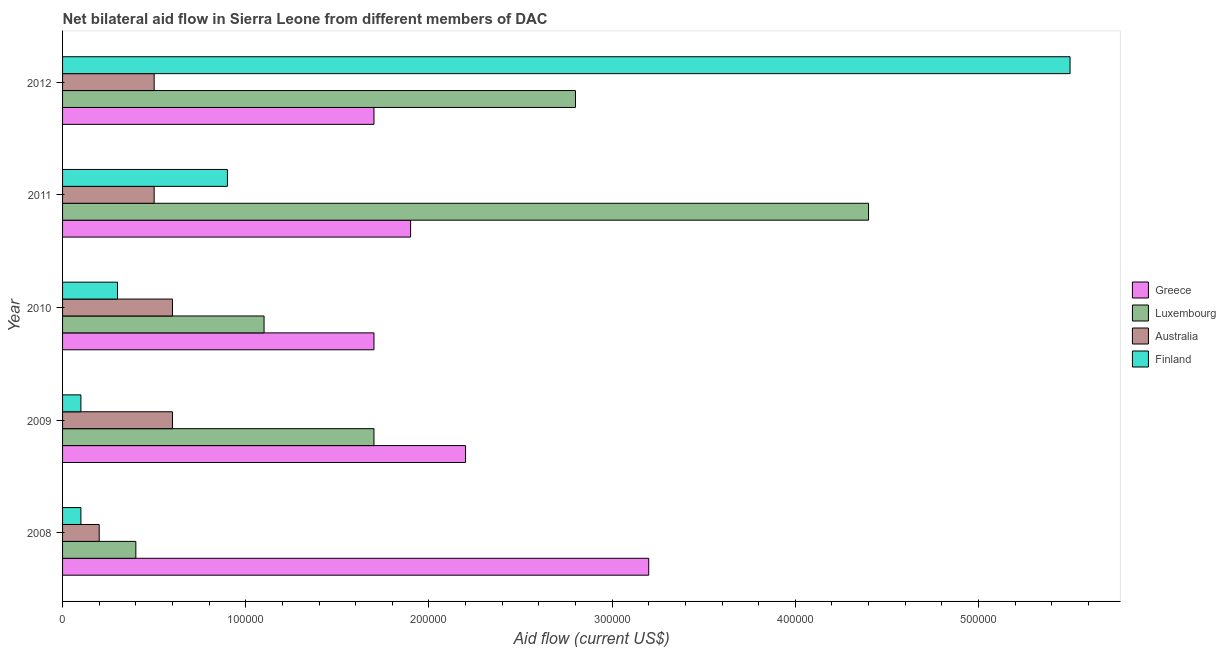How many groups of bars are there?
Provide a short and direct response. 5. How many bars are there on the 5th tick from the bottom?
Offer a very short reply. 4. In how many cases, is the number of bars for a given year not equal to the number of legend labels?
Ensure brevity in your answer.  0. What is the amount of aid given by greece in 2011?
Provide a short and direct response. 1.90e+05. Across all years, what is the maximum amount of aid given by luxembourg?
Offer a terse response. 4.40e+05. Across all years, what is the minimum amount of aid given by finland?
Ensure brevity in your answer.  10000. What is the total amount of aid given by australia in the graph?
Provide a short and direct response. 2.40e+05. What is the difference between the amount of aid given by finland in 2010 and that in 2012?
Offer a terse response. -5.20e+05. What is the difference between the amount of aid given by greece in 2010 and the amount of aid given by australia in 2011?
Ensure brevity in your answer.  1.20e+05. What is the average amount of aid given by greece per year?
Provide a succinct answer. 2.14e+05. In the year 2009, what is the difference between the amount of aid given by greece and amount of aid given by australia?
Offer a terse response. 1.60e+05. In how many years, is the amount of aid given by greece greater than 360000 US$?
Offer a very short reply. 0. What is the ratio of the amount of aid given by greece in 2009 to that in 2011?
Your answer should be compact. 1.16. What is the difference between the highest and the lowest amount of aid given by finland?
Give a very brief answer. 5.40e+05. Is the sum of the amount of aid given by luxembourg in 2008 and 2010 greater than the maximum amount of aid given by finland across all years?
Your answer should be compact. No. Is it the case that in every year, the sum of the amount of aid given by luxembourg and amount of aid given by australia is greater than the sum of amount of aid given by greece and amount of aid given by finland?
Your answer should be very brief. No. What does the 4th bar from the top in 2010 represents?
Offer a very short reply. Greece. What does the 2nd bar from the bottom in 2012 represents?
Your answer should be compact. Luxembourg. How many years are there in the graph?
Provide a succinct answer. 5. What is the difference between two consecutive major ticks on the X-axis?
Make the answer very short. 1.00e+05. Does the graph contain grids?
Offer a very short reply. No. How many legend labels are there?
Your answer should be very brief. 4. What is the title of the graph?
Provide a succinct answer. Net bilateral aid flow in Sierra Leone from different members of DAC. What is the label or title of the X-axis?
Offer a very short reply. Aid flow (current US$). What is the label or title of the Y-axis?
Make the answer very short. Year. What is the Aid flow (current US$) of Greece in 2008?
Ensure brevity in your answer.  3.20e+05. What is the Aid flow (current US$) in Greece in 2009?
Offer a terse response. 2.20e+05. What is the Aid flow (current US$) of Australia in 2009?
Ensure brevity in your answer.  6.00e+04. What is the Aid flow (current US$) in Greece in 2010?
Provide a short and direct response. 1.70e+05. What is the Aid flow (current US$) in Greece in 2011?
Offer a terse response. 1.90e+05. What is the Aid flow (current US$) of Luxembourg in 2011?
Ensure brevity in your answer.  4.40e+05. What is the Aid flow (current US$) in Finland in 2011?
Offer a very short reply. 9.00e+04. What is the Aid flow (current US$) in Greece in 2012?
Offer a very short reply. 1.70e+05. Across all years, what is the maximum Aid flow (current US$) in Greece?
Keep it short and to the point. 3.20e+05. Across all years, what is the maximum Aid flow (current US$) in Luxembourg?
Your answer should be compact. 4.40e+05. Across all years, what is the maximum Aid flow (current US$) of Australia?
Your response must be concise. 6.00e+04. Across all years, what is the maximum Aid flow (current US$) of Finland?
Make the answer very short. 5.50e+05. Across all years, what is the minimum Aid flow (current US$) in Luxembourg?
Your answer should be very brief. 4.00e+04. Across all years, what is the minimum Aid flow (current US$) in Finland?
Your answer should be compact. 10000. What is the total Aid flow (current US$) of Greece in the graph?
Ensure brevity in your answer.  1.07e+06. What is the total Aid flow (current US$) of Luxembourg in the graph?
Ensure brevity in your answer.  1.04e+06. What is the total Aid flow (current US$) of Australia in the graph?
Your answer should be compact. 2.40e+05. What is the total Aid flow (current US$) in Finland in the graph?
Your response must be concise. 6.90e+05. What is the difference between the Aid flow (current US$) in Greece in 2008 and that in 2009?
Give a very brief answer. 1.00e+05. What is the difference between the Aid flow (current US$) in Greece in 2008 and that in 2010?
Make the answer very short. 1.50e+05. What is the difference between the Aid flow (current US$) of Luxembourg in 2008 and that in 2010?
Make the answer very short. -7.00e+04. What is the difference between the Aid flow (current US$) in Greece in 2008 and that in 2011?
Offer a terse response. 1.30e+05. What is the difference between the Aid flow (current US$) of Luxembourg in 2008 and that in 2011?
Your answer should be compact. -4.00e+05. What is the difference between the Aid flow (current US$) of Australia in 2008 and that in 2011?
Provide a succinct answer. -3.00e+04. What is the difference between the Aid flow (current US$) of Australia in 2008 and that in 2012?
Offer a terse response. -3.00e+04. What is the difference between the Aid flow (current US$) of Finland in 2008 and that in 2012?
Make the answer very short. -5.40e+05. What is the difference between the Aid flow (current US$) of Greece in 2009 and that in 2010?
Your answer should be compact. 5.00e+04. What is the difference between the Aid flow (current US$) of Luxembourg in 2009 and that in 2010?
Ensure brevity in your answer.  6.00e+04. What is the difference between the Aid flow (current US$) of Australia in 2009 and that in 2010?
Ensure brevity in your answer.  0. What is the difference between the Aid flow (current US$) in Finland in 2009 and that in 2010?
Your response must be concise. -2.00e+04. What is the difference between the Aid flow (current US$) of Greece in 2009 and that in 2011?
Your answer should be very brief. 3.00e+04. What is the difference between the Aid flow (current US$) of Luxembourg in 2009 and that in 2011?
Make the answer very short. -2.70e+05. What is the difference between the Aid flow (current US$) of Australia in 2009 and that in 2011?
Offer a terse response. 10000. What is the difference between the Aid flow (current US$) in Finland in 2009 and that in 2012?
Ensure brevity in your answer.  -5.40e+05. What is the difference between the Aid flow (current US$) of Greece in 2010 and that in 2011?
Provide a short and direct response. -2.00e+04. What is the difference between the Aid flow (current US$) of Luxembourg in 2010 and that in 2011?
Give a very brief answer. -3.30e+05. What is the difference between the Aid flow (current US$) of Australia in 2010 and that in 2011?
Keep it short and to the point. 10000. What is the difference between the Aid flow (current US$) in Finland in 2010 and that in 2011?
Your answer should be very brief. -6.00e+04. What is the difference between the Aid flow (current US$) in Australia in 2010 and that in 2012?
Your response must be concise. 10000. What is the difference between the Aid flow (current US$) in Finland in 2010 and that in 2012?
Offer a terse response. -5.20e+05. What is the difference between the Aid flow (current US$) in Australia in 2011 and that in 2012?
Ensure brevity in your answer.  0. What is the difference between the Aid flow (current US$) in Finland in 2011 and that in 2012?
Provide a succinct answer. -4.60e+05. What is the difference between the Aid flow (current US$) in Greece in 2008 and the Aid flow (current US$) in Luxembourg in 2009?
Your response must be concise. 1.50e+05. What is the difference between the Aid flow (current US$) of Greece in 2008 and the Aid flow (current US$) of Australia in 2009?
Your response must be concise. 2.60e+05. What is the difference between the Aid flow (current US$) in Greece in 2008 and the Aid flow (current US$) in Finland in 2009?
Offer a very short reply. 3.10e+05. What is the difference between the Aid flow (current US$) of Australia in 2008 and the Aid flow (current US$) of Finland in 2009?
Offer a terse response. 10000. What is the difference between the Aid flow (current US$) of Greece in 2008 and the Aid flow (current US$) of Luxembourg in 2010?
Ensure brevity in your answer.  2.10e+05. What is the difference between the Aid flow (current US$) of Greece in 2008 and the Aid flow (current US$) of Australia in 2010?
Ensure brevity in your answer.  2.60e+05. What is the difference between the Aid flow (current US$) in Greece in 2008 and the Aid flow (current US$) in Finland in 2010?
Provide a succinct answer. 2.90e+05. What is the difference between the Aid flow (current US$) in Luxembourg in 2008 and the Aid flow (current US$) in Australia in 2010?
Offer a very short reply. -2.00e+04. What is the difference between the Aid flow (current US$) of Greece in 2008 and the Aid flow (current US$) of Luxembourg in 2011?
Make the answer very short. -1.20e+05. What is the difference between the Aid flow (current US$) in Greece in 2008 and the Aid flow (current US$) in Finland in 2011?
Your answer should be very brief. 2.30e+05. What is the difference between the Aid flow (current US$) of Luxembourg in 2008 and the Aid flow (current US$) of Australia in 2011?
Make the answer very short. -10000. What is the difference between the Aid flow (current US$) of Luxembourg in 2008 and the Aid flow (current US$) of Finland in 2011?
Offer a very short reply. -5.00e+04. What is the difference between the Aid flow (current US$) in Australia in 2008 and the Aid flow (current US$) in Finland in 2011?
Provide a short and direct response. -7.00e+04. What is the difference between the Aid flow (current US$) of Greece in 2008 and the Aid flow (current US$) of Australia in 2012?
Make the answer very short. 2.70e+05. What is the difference between the Aid flow (current US$) of Luxembourg in 2008 and the Aid flow (current US$) of Australia in 2012?
Ensure brevity in your answer.  -10000. What is the difference between the Aid flow (current US$) of Luxembourg in 2008 and the Aid flow (current US$) of Finland in 2012?
Make the answer very short. -5.10e+05. What is the difference between the Aid flow (current US$) of Australia in 2008 and the Aid flow (current US$) of Finland in 2012?
Your response must be concise. -5.30e+05. What is the difference between the Aid flow (current US$) in Greece in 2009 and the Aid flow (current US$) in Finland in 2010?
Provide a short and direct response. 1.90e+05. What is the difference between the Aid flow (current US$) of Luxembourg in 2009 and the Aid flow (current US$) of Australia in 2010?
Your response must be concise. 1.10e+05. What is the difference between the Aid flow (current US$) of Australia in 2009 and the Aid flow (current US$) of Finland in 2010?
Keep it short and to the point. 3.00e+04. What is the difference between the Aid flow (current US$) of Greece in 2009 and the Aid flow (current US$) of Luxembourg in 2011?
Your answer should be compact. -2.20e+05. What is the difference between the Aid flow (current US$) in Greece in 2009 and the Aid flow (current US$) in Australia in 2011?
Provide a succinct answer. 1.70e+05. What is the difference between the Aid flow (current US$) in Luxembourg in 2009 and the Aid flow (current US$) in Australia in 2011?
Offer a terse response. 1.20e+05. What is the difference between the Aid flow (current US$) of Greece in 2009 and the Aid flow (current US$) of Finland in 2012?
Ensure brevity in your answer.  -3.30e+05. What is the difference between the Aid flow (current US$) in Luxembourg in 2009 and the Aid flow (current US$) in Australia in 2012?
Offer a very short reply. 1.20e+05. What is the difference between the Aid flow (current US$) in Luxembourg in 2009 and the Aid flow (current US$) in Finland in 2012?
Ensure brevity in your answer.  -3.80e+05. What is the difference between the Aid flow (current US$) of Australia in 2009 and the Aid flow (current US$) of Finland in 2012?
Keep it short and to the point. -4.90e+05. What is the difference between the Aid flow (current US$) of Greece in 2010 and the Aid flow (current US$) of Finland in 2011?
Your answer should be very brief. 8.00e+04. What is the difference between the Aid flow (current US$) in Luxembourg in 2010 and the Aid flow (current US$) in Finland in 2011?
Provide a succinct answer. 2.00e+04. What is the difference between the Aid flow (current US$) in Greece in 2010 and the Aid flow (current US$) in Australia in 2012?
Your response must be concise. 1.20e+05. What is the difference between the Aid flow (current US$) of Greece in 2010 and the Aid flow (current US$) of Finland in 2012?
Your answer should be very brief. -3.80e+05. What is the difference between the Aid flow (current US$) of Luxembourg in 2010 and the Aid flow (current US$) of Australia in 2012?
Offer a very short reply. 6.00e+04. What is the difference between the Aid flow (current US$) in Luxembourg in 2010 and the Aid flow (current US$) in Finland in 2012?
Make the answer very short. -4.40e+05. What is the difference between the Aid flow (current US$) in Australia in 2010 and the Aid flow (current US$) in Finland in 2012?
Your answer should be compact. -4.90e+05. What is the difference between the Aid flow (current US$) in Greece in 2011 and the Aid flow (current US$) in Luxembourg in 2012?
Your answer should be very brief. -9.00e+04. What is the difference between the Aid flow (current US$) in Greece in 2011 and the Aid flow (current US$) in Finland in 2012?
Your answer should be compact. -3.60e+05. What is the difference between the Aid flow (current US$) in Australia in 2011 and the Aid flow (current US$) in Finland in 2012?
Make the answer very short. -5.00e+05. What is the average Aid flow (current US$) in Greece per year?
Your answer should be compact. 2.14e+05. What is the average Aid flow (current US$) of Luxembourg per year?
Keep it short and to the point. 2.08e+05. What is the average Aid flow (current US$) of Australia per year?
Make the answer very short. 4.80e+04. What is the average Aid flow (current US$) of Finland per year?
Your answer should be very brief. 1.38e+05. In the year 2008, what is the difference between the Aid flow (current US$) in Greece and Aid flow (current US$) in Australia?
Offer a terse response. 3.00e+05. In the year 2008, what is the difference between the Aid flow (current US$) of Luxembourg and Aid flow (current US$) of Finland?
Ensure brevity in your answer.  3.00e+04. In the year 2008, what is the difference between the Aid flow (current US$) in Australia and Aid flow (current US$) in Finland?
Offer a very short reply. 10000. In the year 2009, what is the difference between the Aid flow (current US$) in Greece and Aid flow (current US$) in Australia?
Provide a short and direct response. 1.60e+05. In the year 2009, what is the difference between the Aid flow (current US$) of Greece and Aid flow (current US$) of Finland?
Offer a terse response. 2.10e+05. In the year 2009, what is the difference between the Aid flow (current US$) of Luxembourg and Aid flow (current US$) of Australia?
Your answer should be compact. 1.10e+05. In the year 2009, what is the difference between the Aid flow (current US$) of Luxembourg and Aid flow (current US$) of Finland?
Your answer should be very brief. 1.60e+05. In the year 2009, what is the difference between the Aid flow (current US$) in Australia and Aid flow (current US$) in Finland?
Offer a very short reply. 5.00e+04. In the year 2010, what is the difference between the Aid flow (current US$) in Luxembourg and Aid flow (current US$) in Australia?
Offer a terse response. 5.00e+04. In the year 2010, what is the difference between the Aid flow (current US$) of Australia and Aid flow (current US$) of Finland?
Your answer should be compact. 3.00e+04. In the year 2011, what is the difference between the Aid flow (current US$) in Greece and Aid flow (current US$) in Australia?
Your answer should be very brief. 1.40e+05. In the year 2011, what is the difference between the Aid flow (current US$) in Greece and Aid flow (current US$) in Finland?
Offer a terse response. 1.00e+05. In the year 2011, what is the difference between the Aid flow (current US$) of Luxembourg and Aid flow (current US$) of Australia?
Provide a short and direct response. 3.90e+05. In the year 2011, what is the difference between the Aid flow (current US$) in Luxembourg and Aid flow (current US$) in Finland?
Your answer should be very brief. 3.50e+05. In the year 2011, what is the difference between the Aid flow (current US$) of Australia and Aid flow (current US$) of Finland?
Give a very brief answer. -4.00e+04. In the year 2012, what is the difference between the Aid flow (current US$) of Greece and Aid flow (current US$) of Luxembourg?
Offer a very short reply. -1.10e+05. In the year 2012, what is the difference between the Aid flow (current US$) of Greece and Aid flow (current US$) of Finland?
Your answer should be very brief. -3.80e+05. In the year 2012, what is the difference between the Aid flow (current US$) of Australia and Aid flow (current US$) of Finland?
Make the answer very short. -5.00e+05. What is the ratio of the Aid flow (current US$) in Greece in 2008 to that in 2009?
Give a very brief answer. 1.45. What is the ratio of the Aid flow (current US$) of Luxembourg in 2008 to that in 2009?
Offer a very short reply. 0.24. What is the ratio of the Aid flow (current US$) in Greece in 2008 to that in 2010?
Your answer should be very brief. 1.88. What is the ratio of the Aid flow (current US$) in Luxembourg in 2008 to that in 2010?
Ensure brevity in your answer.  0.36. What is the ratio of the Aid flow (current US$) in Australia in 2008 to that in 2010?
Provide a succinct answer. 0.33. What is the ratio of the Aid flow (current US$) of Finland in 2008 to that in 2010?
Make the answer very short. 0.33. What is the ratio of the Aid flow (current US$) in Greece in 2008 to that in 2011?
Ensure brevity in your answer.  1.68. What is the ratio of the Aid flow (current US$) in Luxembourg in 2008 to that in 2011?
Make the answer very short. 0.09. What is the ratio of the Aid flow (current US$) of Australia in 2008 to that in 2011?
Provide a succinct answer. 0.4. What is the ratio of the Aid flow (current US$) of Finland in 2008 to that in 2011?
Provide a short and direct response. 0.11. What is the ratio of the Aid flow (current US$) of Greece in 2008 to that in 2012?
Make the answer very short. 1.88. What is the ratio of the Aid flow (current US$) of Luxembourg in 2008 to that in 2012?
Offer a very short reply. 0.14. What is the ratio of the Aid flow (current US$) of Australia in 2008 to that in 2012?
Give a very brief answer. 0.4. What is the ratio of the Aid flow (current US$) of Finland in 2008 to that in 2012?
Offer a very short reply. 0.02. What is the ratio of the Aid flow (current US$) in Greece in 2009 to that in 2010?
Provide a short and direct response. 1.29. What is the ratio of the Aid flow (current US$) of Luxembourg in 2009 to that in 2010?
Offer a terse response. 1.55. What is the ratio of the Aid flow (current US$) in Greece in 2009 to that in 2011?
Your answer should be very brief. 1.16. What is the ratio of the Aid flow (current US$) of Luxembourg in 2009 to that in 2011?
Give a very brief answer. 0.39. What is the ratio of the Aid flow (current US$) in Australia in 2009 to that in 2011?
Give a very brief answer. 1.2. What is the ratio of the Aid flow (current US$) of Greece in 2009 to that in 2012?
Your response must be concise. 1.29. What is the ratio of the Aid flow (current US$) of Luxembourg in 2009 to that in 2012?
Your answer should be compact. 0.61. What is the ratio of the Aid flow (current US$) of Australia in 2009 to that in 2012?
Offer a terse response. 1.2. What is the ratio of the Aid flow (current US$) of Finland in 2009 to that in 2012?
Provide a succinct answer. 0.02. What is the ratio of the Aid flow (current US$) of Greece in 2010 to that in 2011?
Ensure brevity in your answer.  0.89. What is the ratio of the Aid flow (current US$) in Australia in 2010 to that in 2011?
Make the answer very short. 1.2. What is the ratio of the Aid flow (current US$) of Luxembourg in 2010 to that in 2012?
Make the answer very short. 0.39. What is the ratio of the Aid flow (current US$) in Australia in 2010 to that in 2012?
Your response must be concise. 1.2. What is the ratio of the Aid flow (current US$) in Finland in 2010 to that in 2012?
Your answer should be very brief. 0.05. What is the ratio of the Aid flow (current US$) of Greece in 2011 to that in 2012?
Keep it short and to the point. 1.12. What is the ratio of the Aid flow (current US$) in Luxembourg in 2011 to that in 2012?
Offer a very short reply. 1.57. What is the ratio of the Aid flow (current US$) of Finland in 2011 to that in 2012?
Your answer should be compact. 0.16. What is the difference between the highest and the second highest Aid flow (current US$) in Greece?
Offer a very short reply. 1.00e+05. What is the difference between the highest and the second highest Aid flow (current US$) in Luxembourg?
Your answer should be very brief. 1.60e+05. What is the difference between the highest and the lowest Aid flow (current US$) of Greece?
Your response must be concise. 1.50e+05. What is the difference between the highest and the lowest Aid flow (current US$) of Finland?
Your response must be concise. 5.40e+05. 